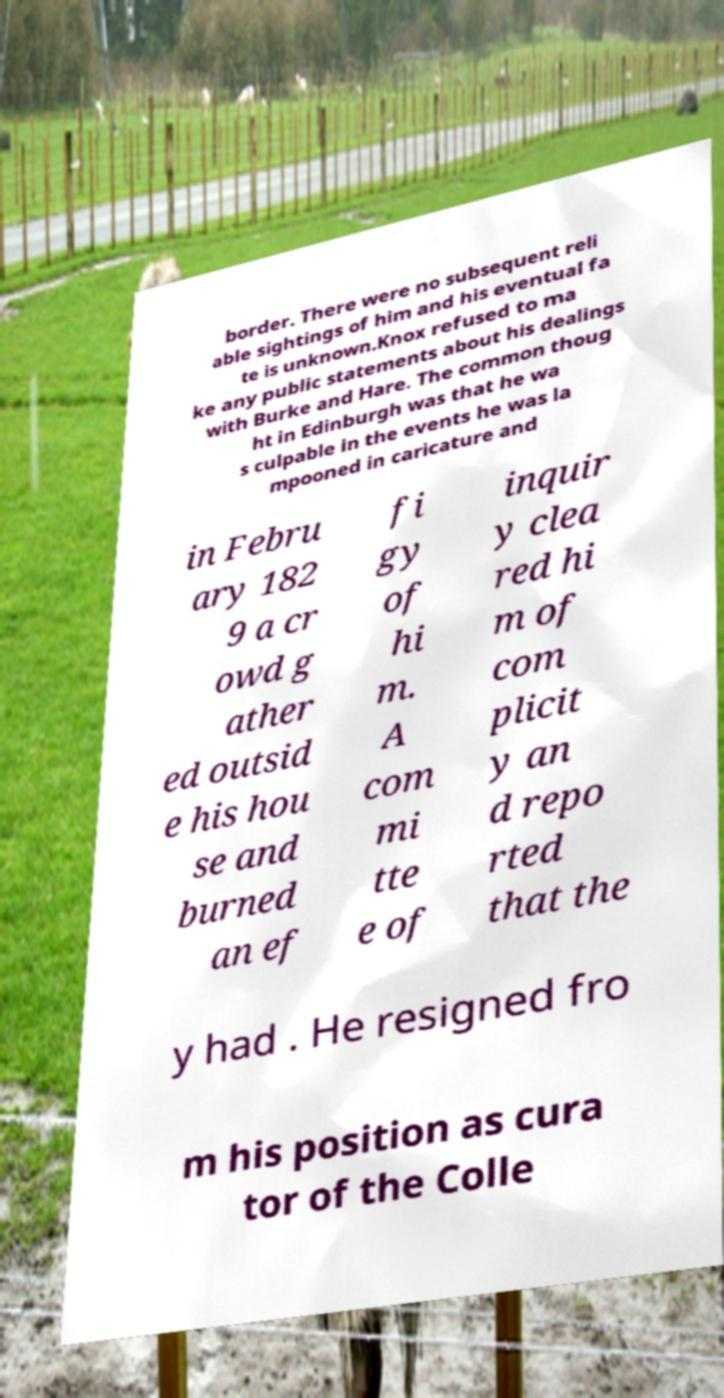Can you read and provide the text displayed in the image?This photo seems to have some interesting text. Can you extract and type it out for me? border. There were no subsequent reli able sightings of him and his eventual fa te is unknown.Knox refused to ma ke any public statements about his dealings with Burke and Hare. The common thoug ht in Edinburgh was that he wa s culpable in the events he was la mpooned in caricature and in Febru ary 182 9 a cr owd g ather ed outsid e his hou se and burned an ef fi gy of hi m. A com mi tte e of inquir y clea red hi m of com plicit y an d repo rted that the y had . He resigned fro m his position as cura tor of the Colle 